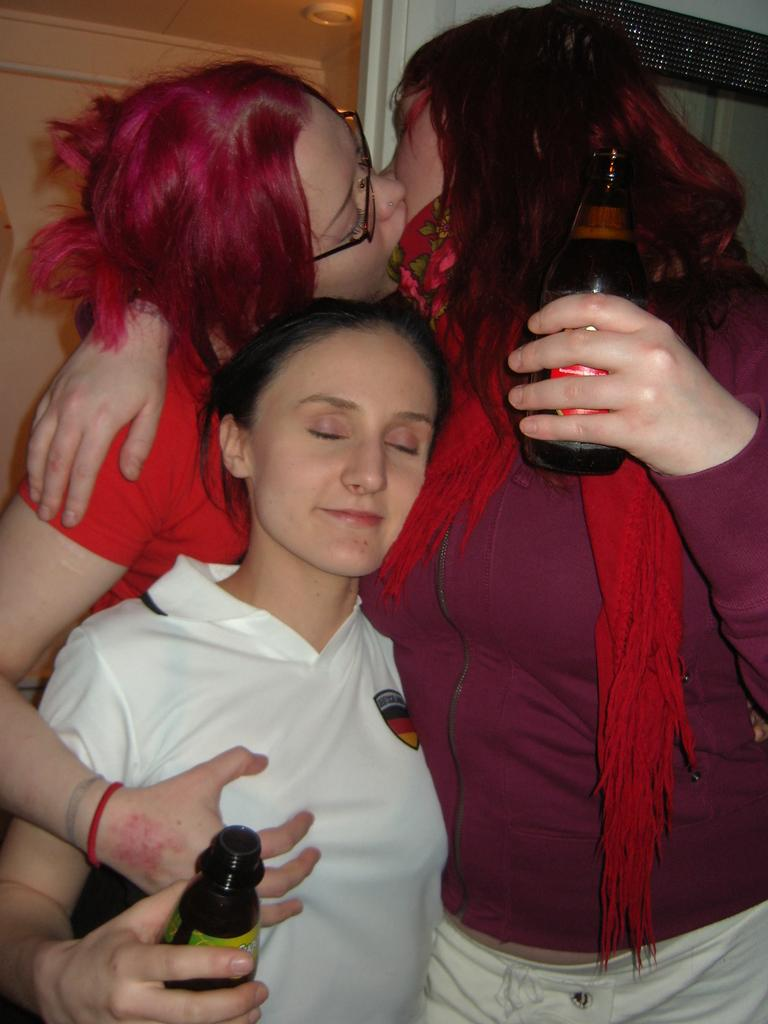Who is present in the image? There are women in the image. What are the women doing in the image? The women are standing in the image. What objects are the women holding in their hands? The women are holding wine glasses in their hands. What degree does the woman on the left have in the image? There is no information about the women's degrees in the image. What type of toothbrush is the woman on the right using in the image? There is no toothbrush present in the image. 